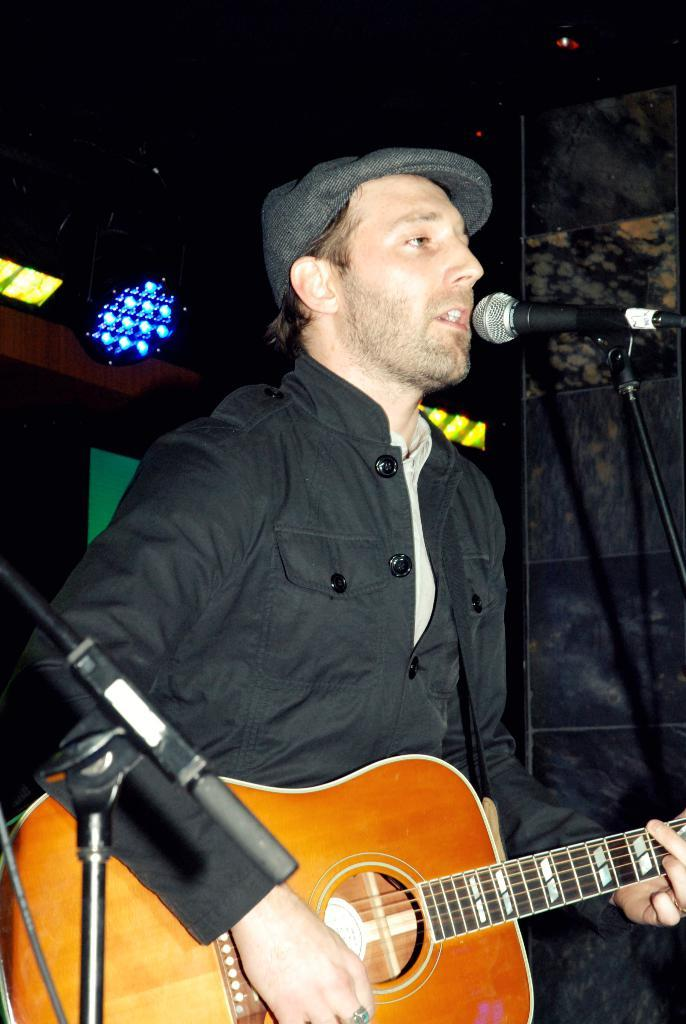What is the person in the image doing? The person is holding a guitar and singing into a microphone. What object is the person using to amplify their voice? The person is using a microphone to amplify their voice. What instrument is the person playing? The person is playing a guitar. What type of muscle is being exercised by the person while playing the guitar? There is no indication in the image that the person is exercising any muscles while playing the guitar. 